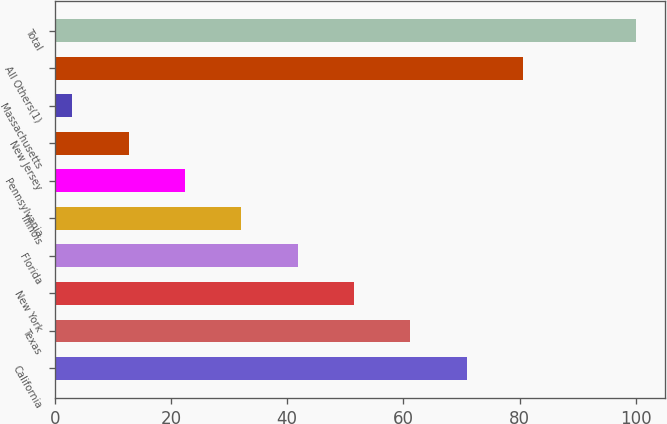<chart> <loc_0><loc_0><loc_500><loc_500><bar_chart><fcel>California<fcel>Texas<fcel>New York<fcel>Florida<fcel>Illinois<fcel>Pennsylvania<fcel>New Jersey<fcel>Massachusetts<fcel>All Others(1)<fcel>Total<nl><fcel>70.9<fcel>61.2<fcel>51.5<fcel>41.8<fcel>32.1<fcel>22.4<fcel>12.7<fcel>3<fcel>80.6<fcel>100<nl></chart> 